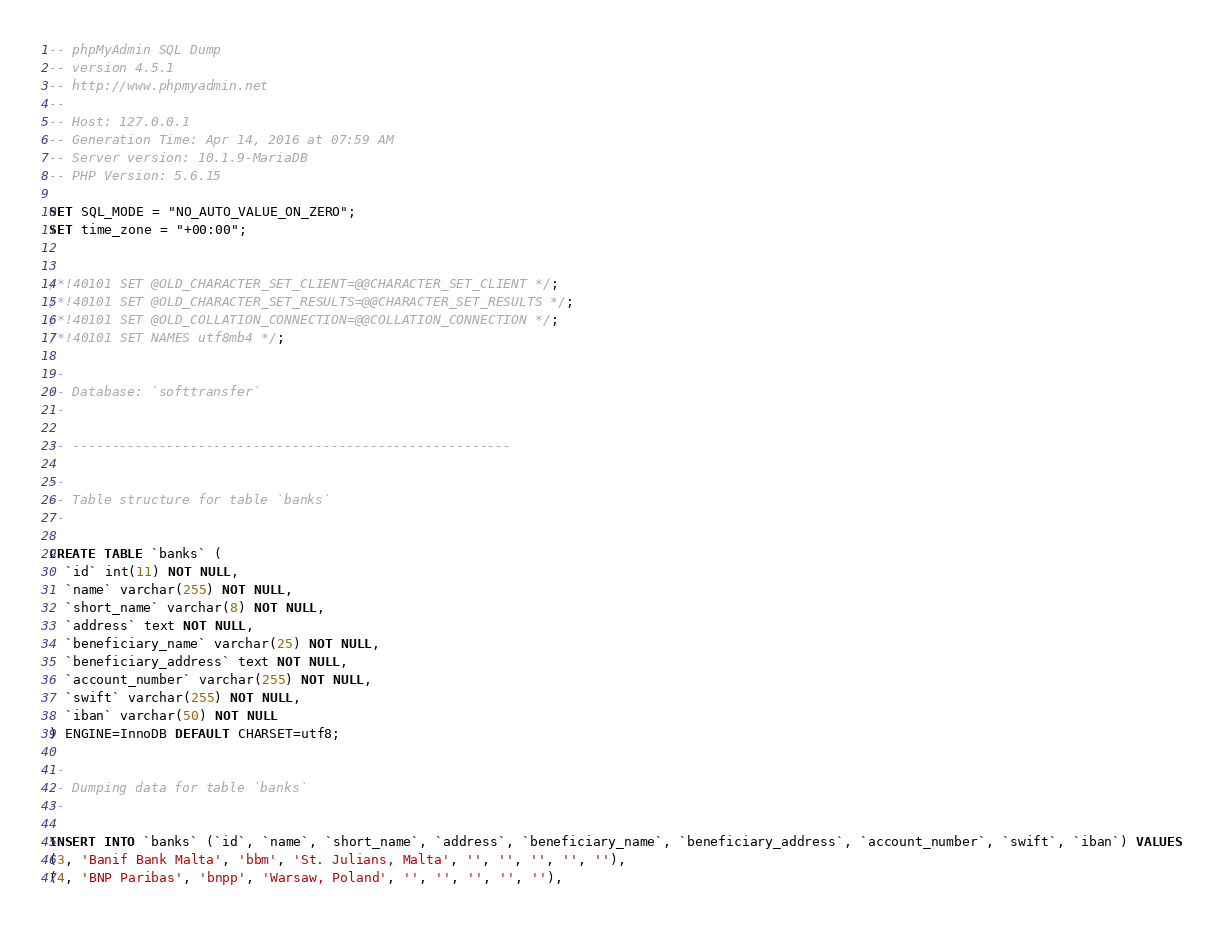<code> <loc_0><loc_0><loc_500><loc_500><_SQL_>-- phpMyAdmin SQL Dump
-- version 4.5.1
-- http://www.phpmyadmin.net
--
-- Host: 127.0.0.1
-- Generation Time: Apr 14, 2016 at 07:59 AM
-- Server version: 10.1.9-MariaDB
-- PHP Version: 5.6.15

SET SQL_MODE = "NO_AUTO_VALUE_ON_ZERO";
SET time_zone = "+00:00";


/*!40101 SET @OLD_CHARACTER_SET_CLIENT=@@CHARACTER_SET_CLIENT */;
/*!40101 SET @OLD_CHARACTER_SET_RESULTS=@@CHARACTER_SET_RESULTS */;
/*!40101 SET @OLD_COLLATION_CONNECTION=@@COLLATION_CONNECTION */;
/*!40101 SET NAMES utf8mb4 */;

--
-- Database: `softtransfer`
--

-- --------------------------------------------------------

--
-- Table structure for table `banks`
--

CREATE TABLE `banks` (
  `id` int(11) NOT NULL,
  `name` varchar(255) NOT NULL,
  `short_name` varchar(8) NOT NULL,
  `address` text NOT NULL,
  `beneficiary_name` varchar(25) NOT NULL,
  `beneficiary_address` text NOT NULL,
  `account_number` varchar(255) NOT NULL,
  `swift` varchar(255) NOT NULL,
  `iban` varchar(50) NOT NULL
) ENGINE=InnoDB DEFAULT CHARSET=utf8;

--
-- Dumping data for table `banks`
--

INSERT INTO `banks` (`id`, `name`, `short_name`, `address`, `beneficiary_name`, `beneficiary_address`, `account_number`, `swift`, `iban`) VALUES
(3, 'Banif Bank Malta', 'bbm', 'St. Julians, Malta', '', '', '', '', ''),
(4, 'BNP Paribas', 'bnpp', 'Warsaw, Poland', '', '', '', '', ''),</code> 